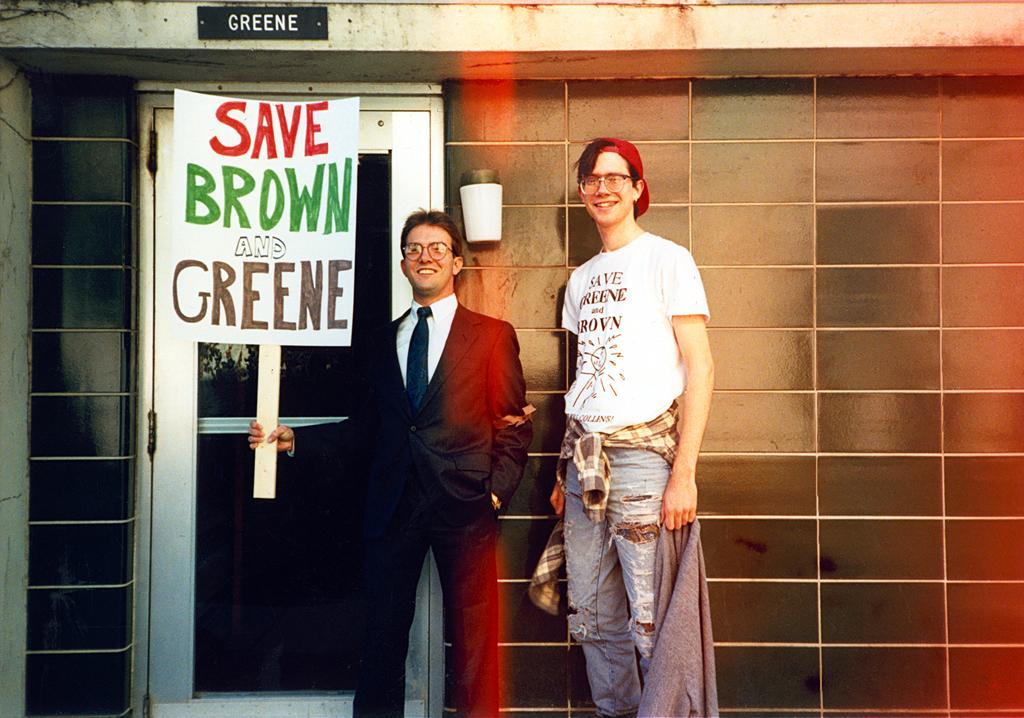In one or two sentences, can you explain what this image depicts? In this picture we can see a person holding a name board with a stick in his hand and smiling. There is a man standing and smiling. We can see a light and a door on this building. There is a text on a chalkboard which is visible on the building. 